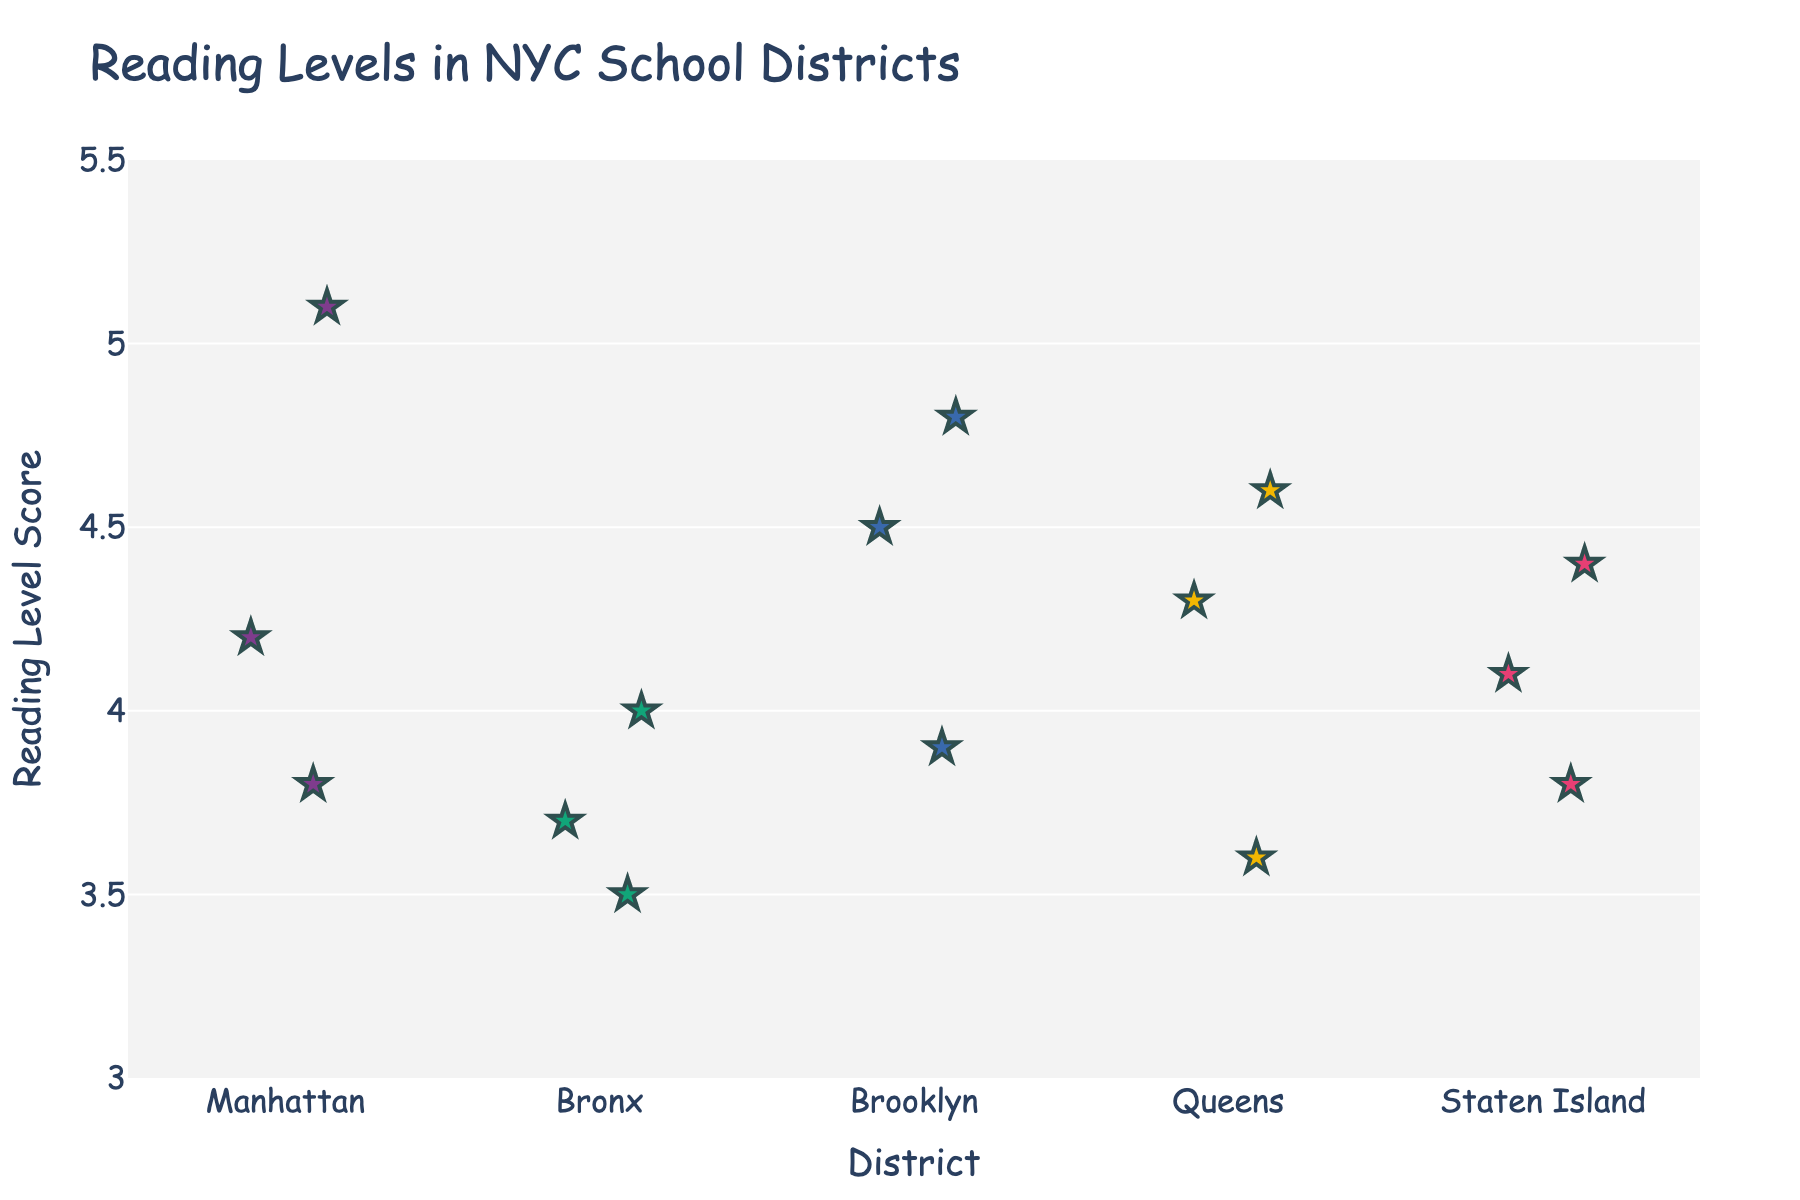What is the title of the plot? The title is located at the top of the plot and describes the main subject of the visual representation.
Answer: Reading Levels in NYC School Districts Which district has the highest reading level score? The highest reading level score is indicated by the data point at the topmost position in the plot. Look for the district that this point belongs to.
Answer: Manhattan How many students' reading levels are shown for the Bronx? The total number of students' reading levels appears as individual data points for each district. Count the points within the Bronx category.
Answer: 3 What is the overall range of reading levels across all districts? To find the range, identify the highest and lowest reading level scores in the plot and subtract the lowest from the highest.
Answer: 3.5 to 5.1 What is the average reading level score for students in Brooklyn? Sum the reading level scores of all students in Brooklyn and divide by the number of Brooklyn students to find the average.
Answer: (4.5 + 3.9 + 4.8) / 3 = 4.4 Which district has the most dispersed reading levels? Dispersed reading levels suggest a greater spread of data points. Compare the spread of points in each district to identify the one with the widest distribution.
Answer: Queens How do the reading levels of students in Staten Island compare to those in the Bronx? Compare the central tendencies and spreads of reading levels between Staten Island and the Bronx by examining the positions of their data points in the plot.
Answer: Staten Island's levels are slightly higher Are there any districts where all students have similar reading levels? Similar reading levels would show data points closely grouped together. Look for districts with tightly clustered data points vertically.
Answer: Queens What is the median reading level score for Queens? Arrange the reading level scores for Queens in numerical order and identify the middle value.
Answer: 4.3 Which student's reading level is closest to the average reading level of Manhattan? Calculate the average reading level for Manhattan, then find the student with the reading level score closest to that average.
Answer: Michael 